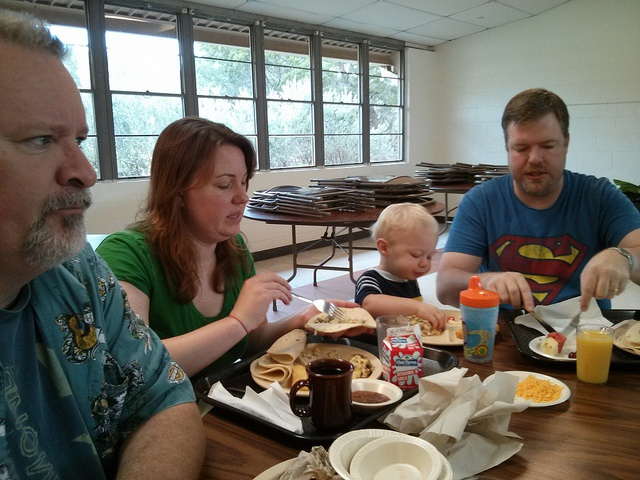Describe the objects in this image and their specific colors. I can see dining table in gray, black, maroon, and darkgray tones, people in gray, black, teal, and maroon tones, people in gray, black, and maroon tones, people in gray, black, maroon, and darkblue tones, and people in gray, brown, black, and tan tones in this image. 